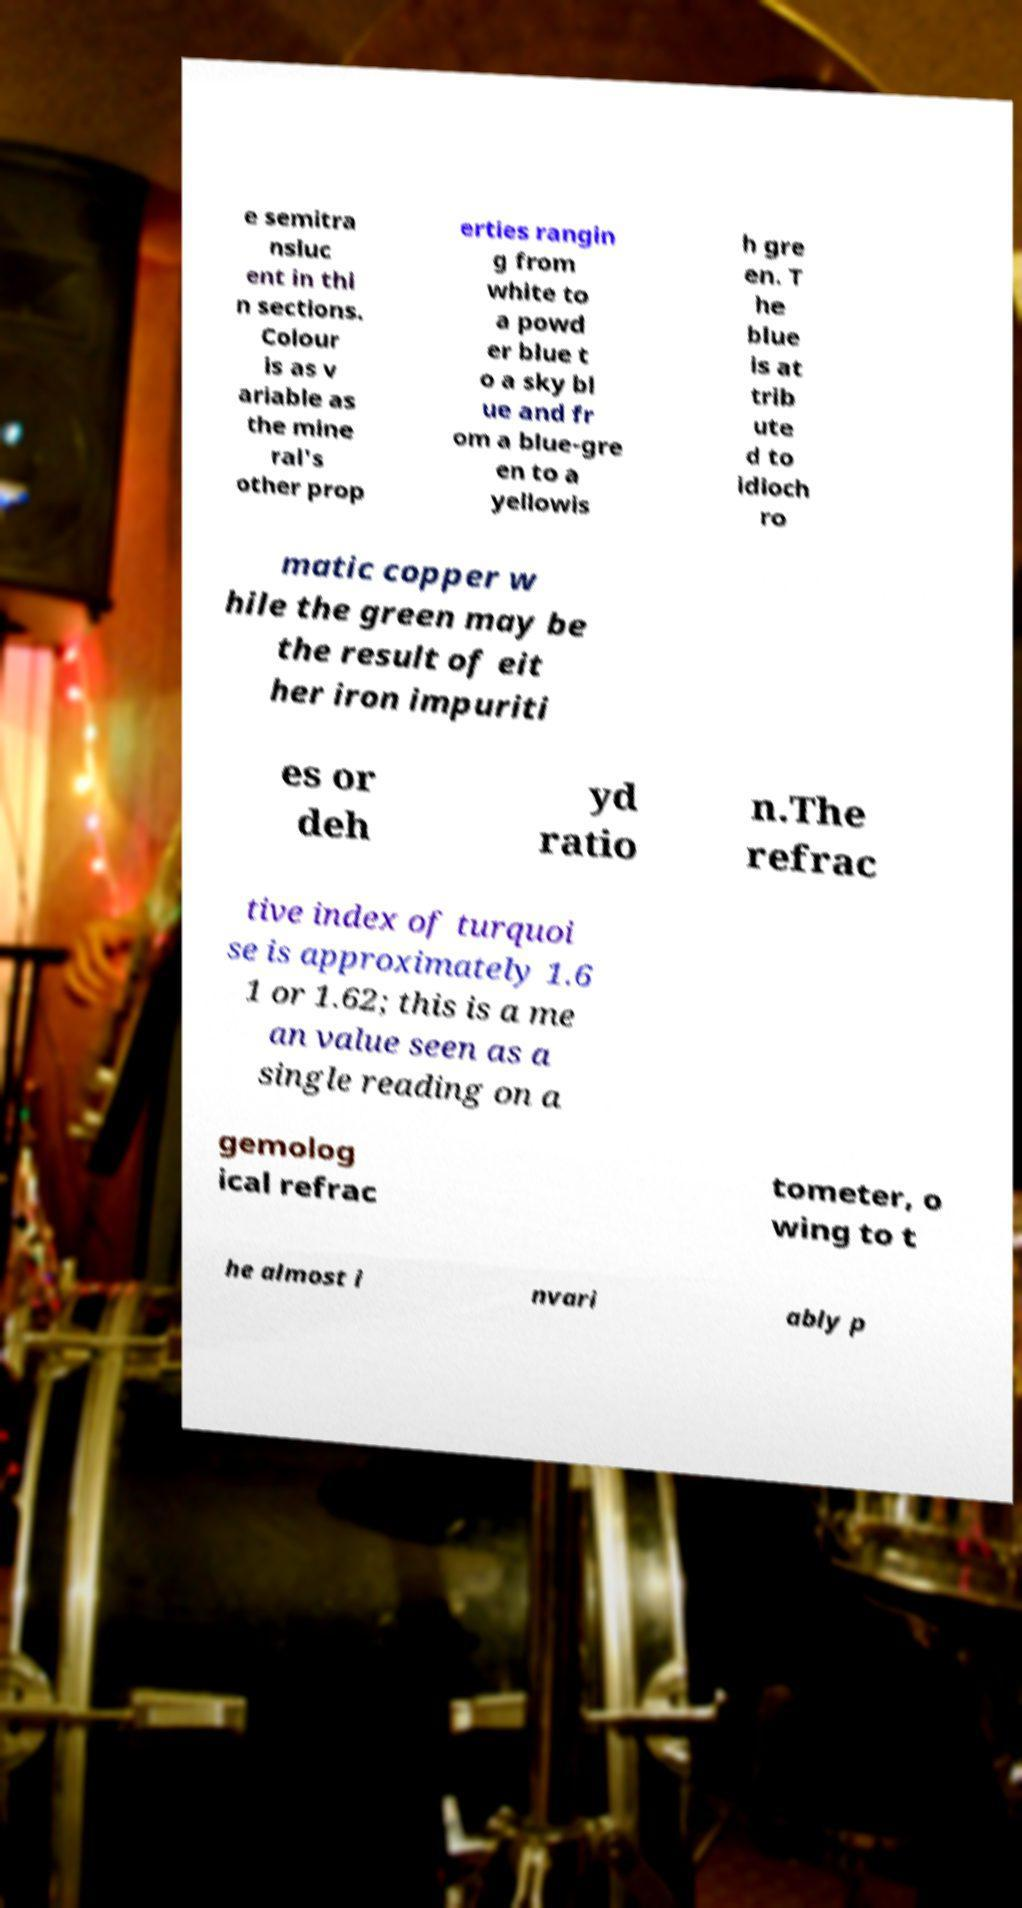Please read and relay the text visible in this image. What does it say? e semitra nsluc ent in thi n sections. Colour is as v ariable as the mine ral's other prop erties rangin g from white to a powd er blue t o a sky bl ue and fr om a blue-gre en to a yellowis h gre en. T he blue is at trib ute d to idioch ro matic copper w hile the green may be the result of eit her iron impuriti es or deh yd ratio n.The refrac tive index of turquoi se is approximately 1.6 1 or 1.62; this is a me an value seen as a single reading on a gemolog ical refrac tometer, o wing to t he almost i nvari ably p 